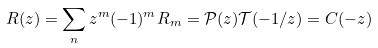Convert formula to latex. <formula><loc_0><loc_0><loc_500><loc_500>R ( z ) = \sum _ { n } z ^ { m } ( - 1 ) ^ { m } R _ { m } = \mathcal { P } ( z ) \mathcal { T } ( - 1 / z ) = C ( - z )</formula> 